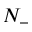<formula> <loc_0><loc_0><loc_500><loc_500>N _ { - }</formula> 